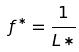<formula> <loc_0><loc_0><loc_500><loc_500>f ^ { * } = \frac { 1 } { L * }</formula> 